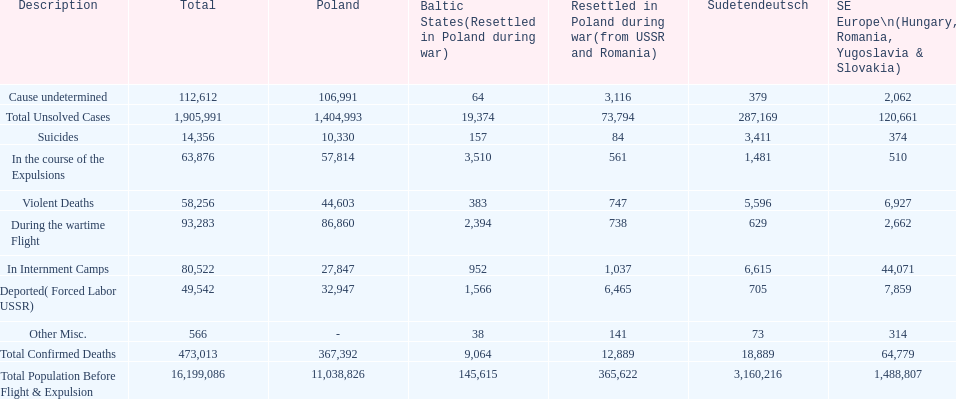Which region had the least total of unsolved cases? Baltic States(Resettled in Poland during war). 